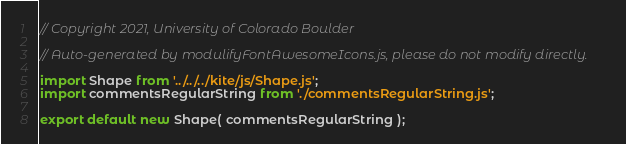<code> <loc_0><loc_0><loc_500><loc_500><_JavaScript_>// Copyright 2021, University of Colorado Boulder

// Auto-generated by modulifyFontAwesomeIcons.js, please do not modify directly.

import Shape from '../../../kite/js/Shape.js';
import commentsRegularString from './commentsRegularString.js';

export default new Shape( commentsRegularString );</code> 